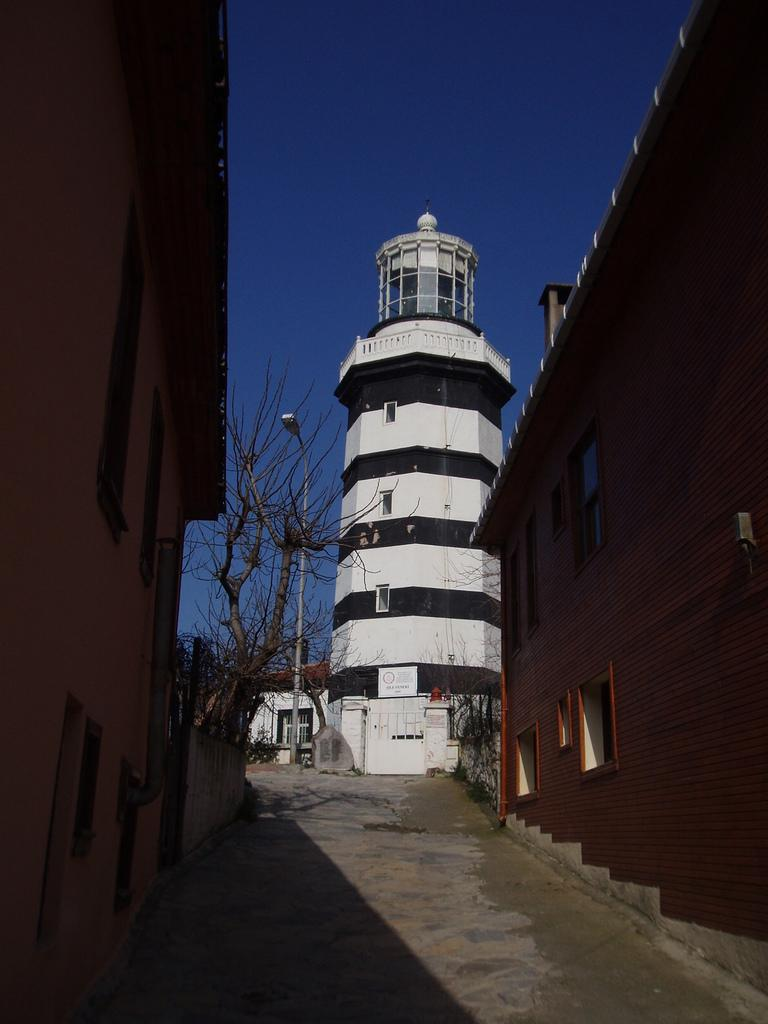What type of structures can be seen in the image? There are buildings in the image. What is located in the center of the image? There is a path in the center of the image. What type of vegetation is present in the image? There are trees in the image. What type of lighting is present in the image? There is a street light pole in the image. What is visible at the top of the image? The sky is visible at the top of the image. What type of scissors can be seen in the aftermath of the police incident in the image? There is no mention of scissors, an aftermath, or a police incident in the image. The image features buildings, a path, trees, a street light pole, and the sky. 